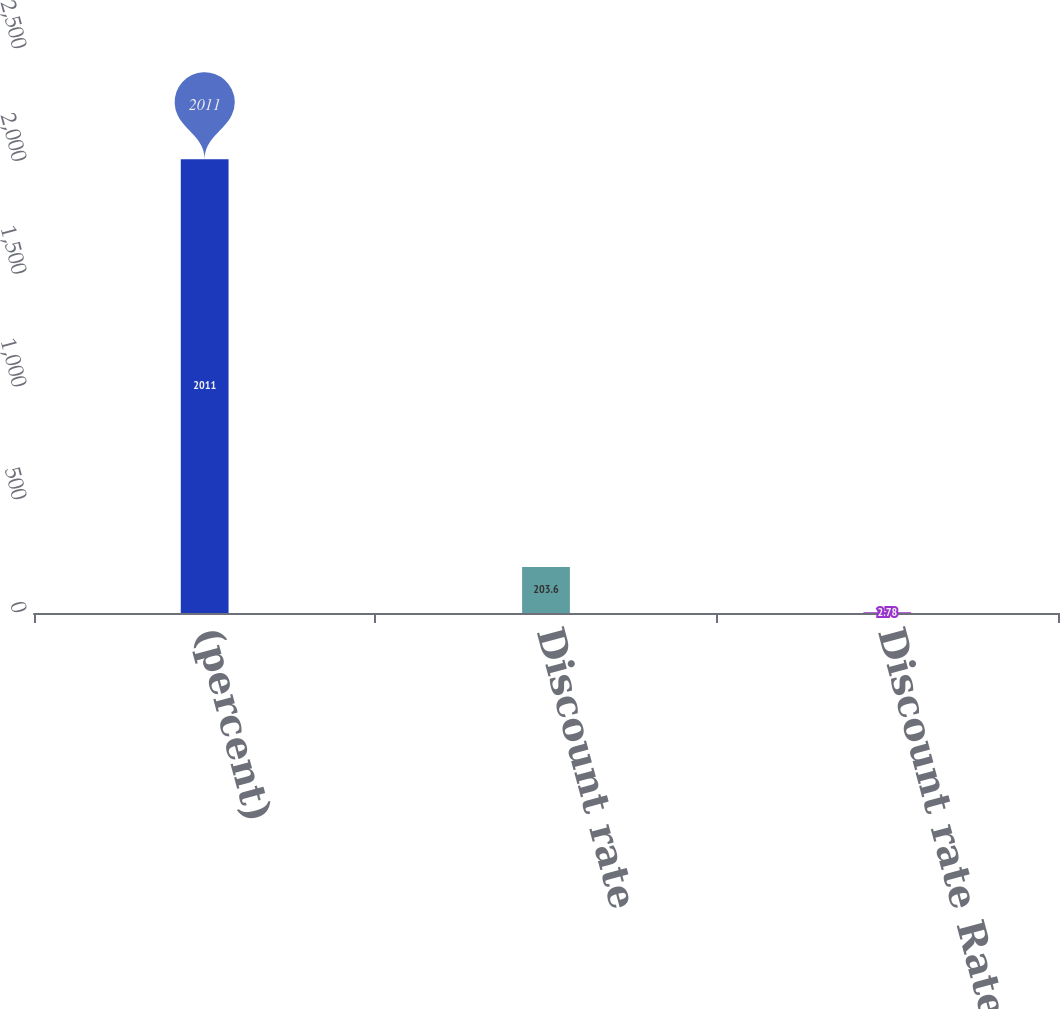Convert chart to OTSL. <chart><loc_0><loc_0><loc_500><loc_500><bar_chart><fcel>(percent)<fcel>Discount rate<fcel>Discount rate Rate of<nl><fcel>2011<fcel>203.6<fcel>2.78<nl></chart> 